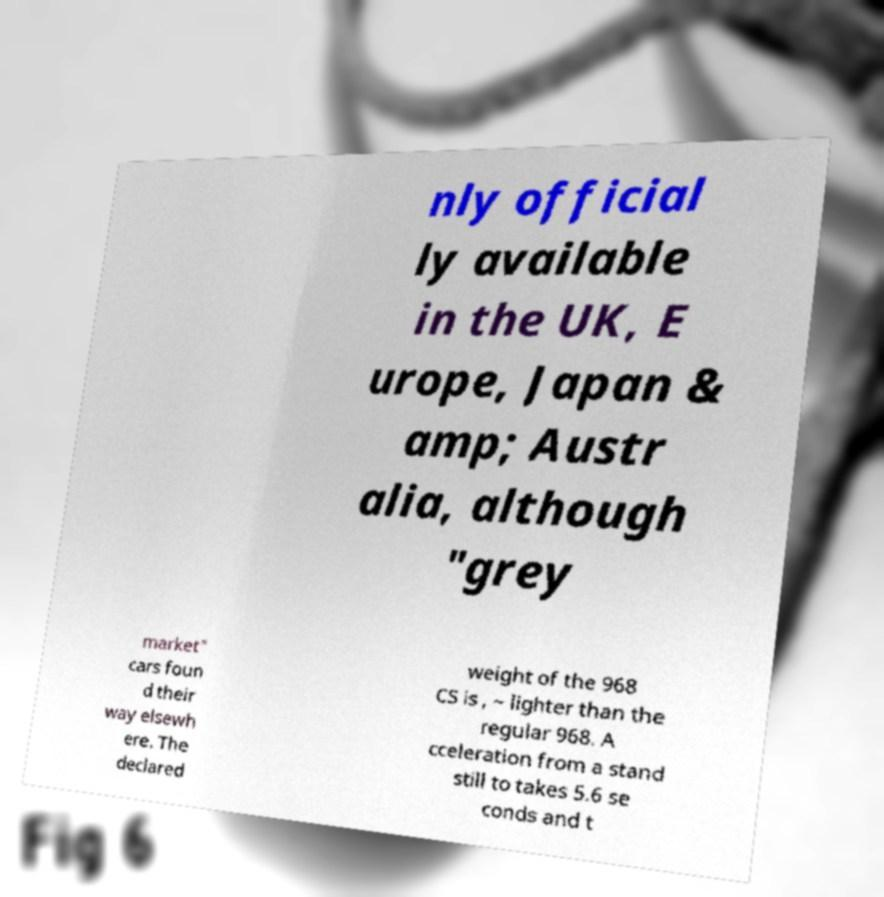What messages or text are displayed in this image? I need them in a readable, typed format. nly official ly available in the UK, E urope, Japan & amp; Austr alia, although "grey market" cars foun d their way elsewh ere. The declared weight of the 968 CS is , ~ lighter than the regular 968. A cceleration from a stand still to takes 5.6 se conds and t 